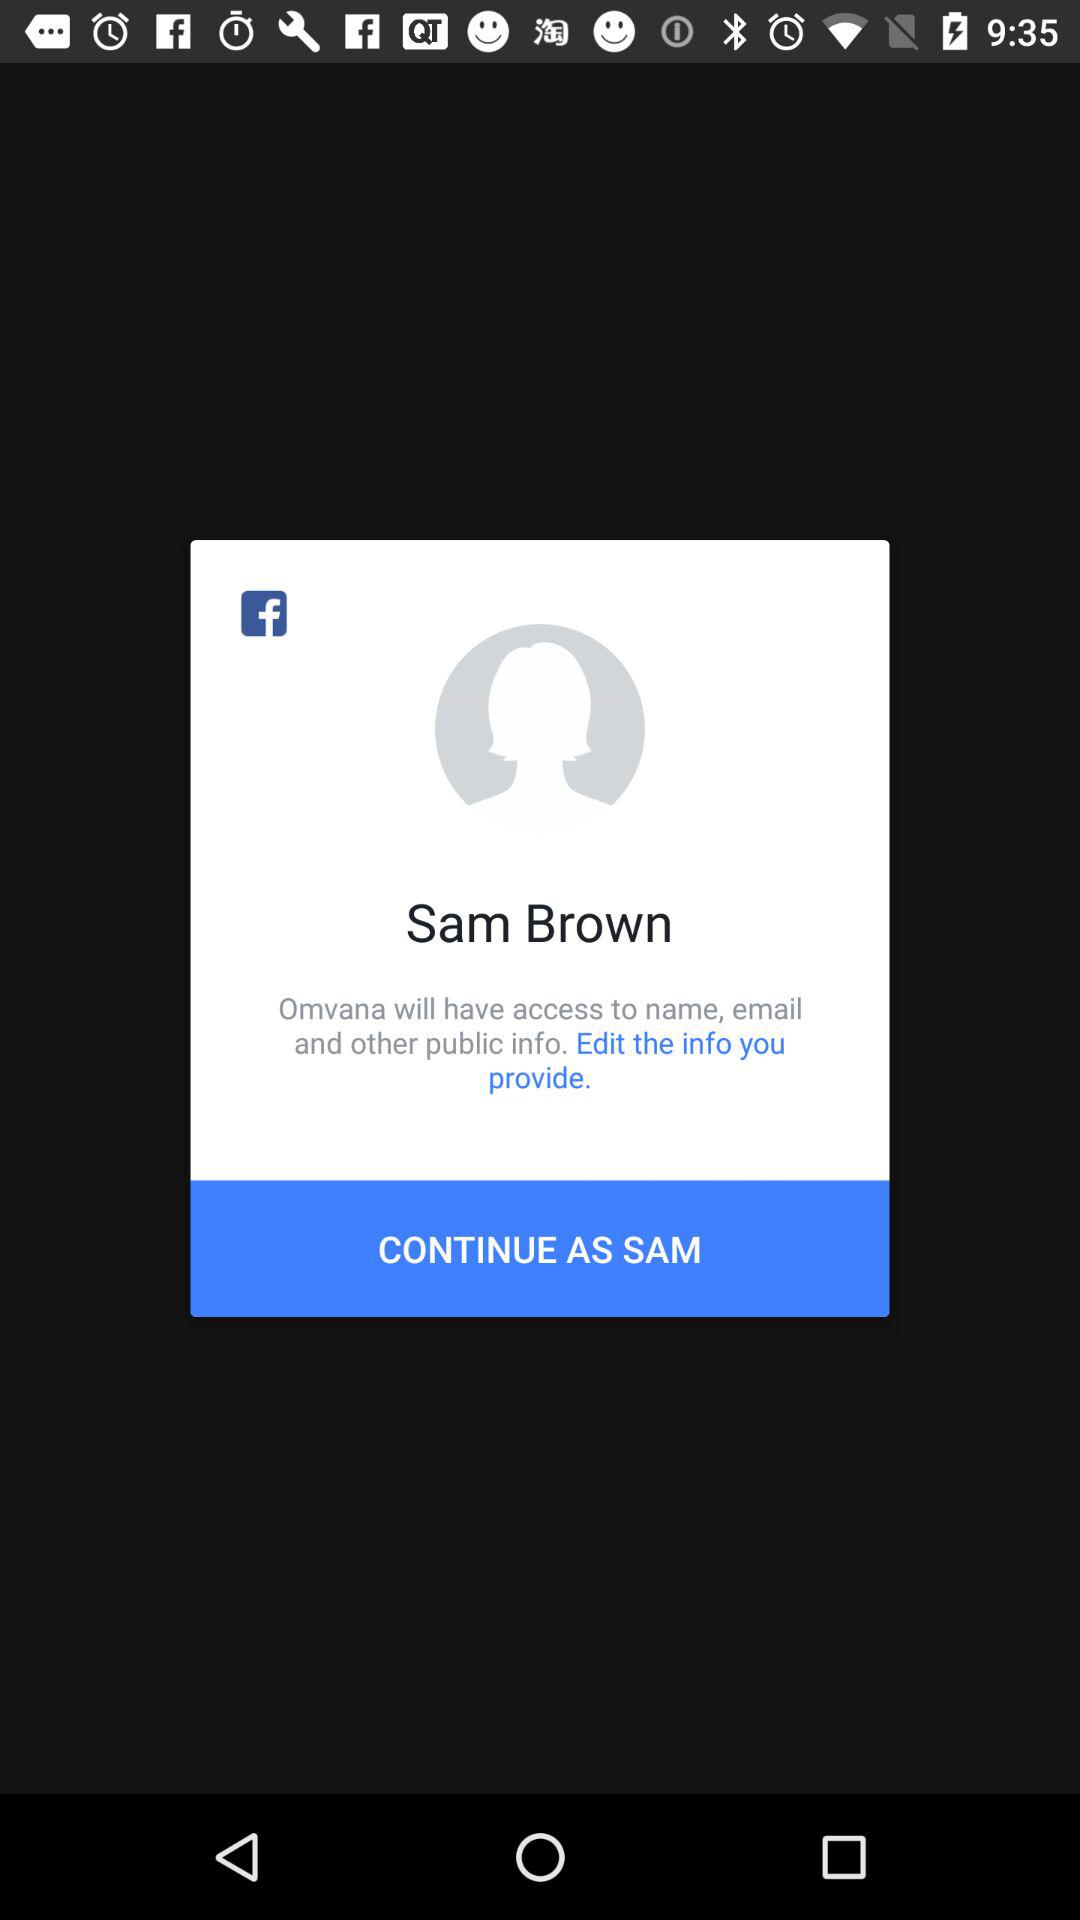What is the name of the user? The name of the user is Sam Brown. 